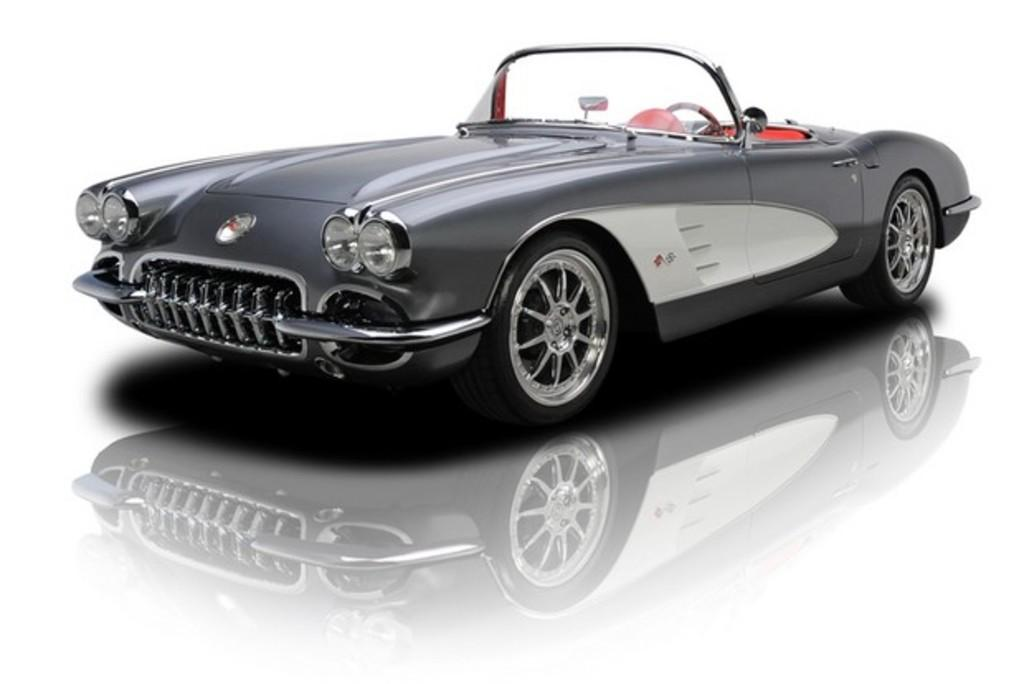What color is the car in the image? The car in the image is brown. What type of flooring can be seen in the image? There are white color tiles in the image. What type of steel is used to make the whistle in the image? There is no whistle present in the image, so it is not possible to determine what type of steel might be used. 